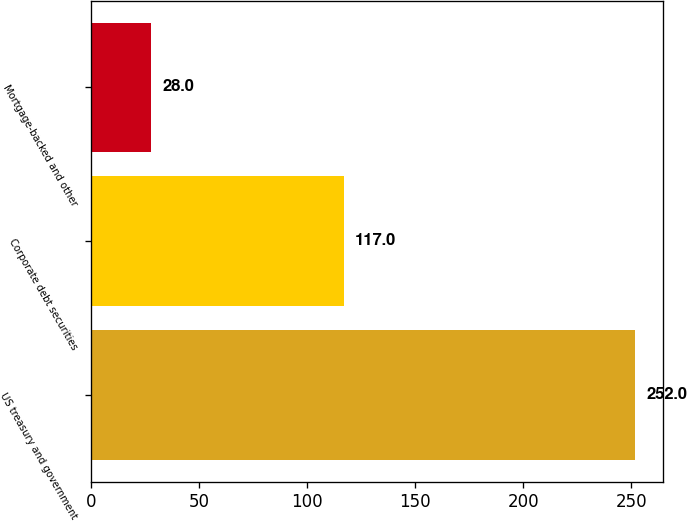Convert chart. <chart><loc_0><loc_0><loc_500><loc_500><bar_chart><fcel>US treasury and government<fcel>Corporate debt securities<fcel>Mortgage-backed and other<nl><fcel>252<fcel>117<fcel>28<nl></chart> 